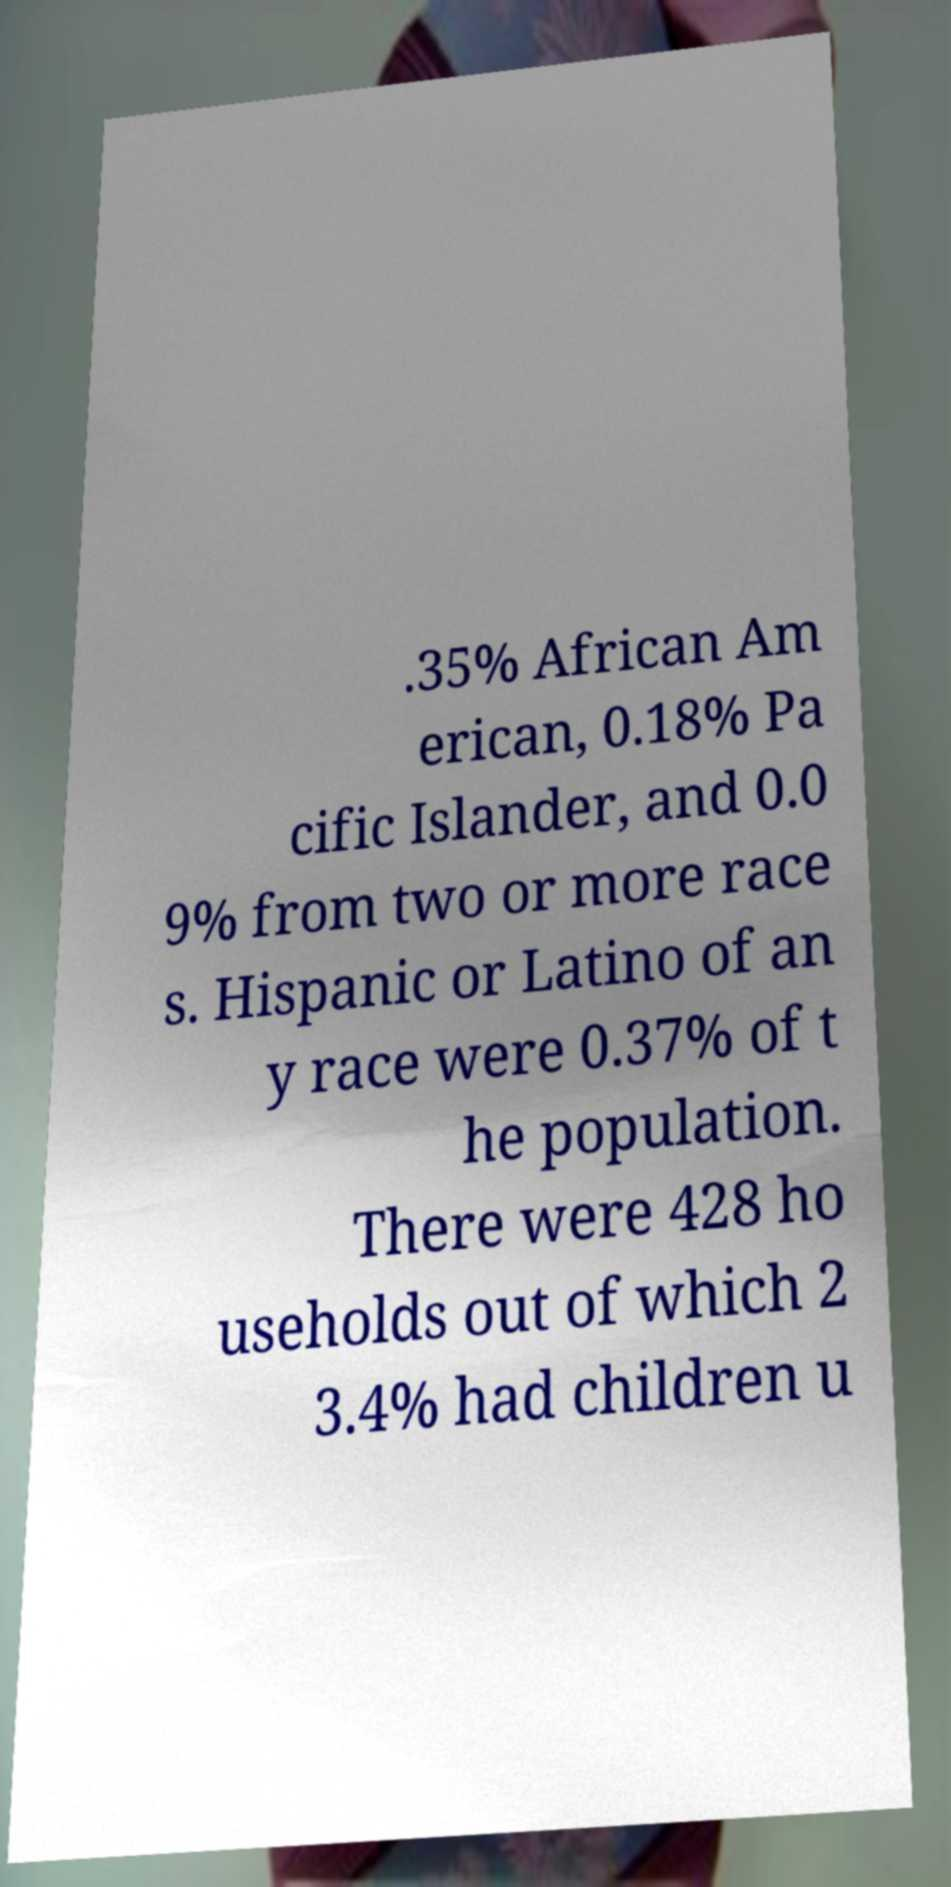Please identify and transcribe the text found in this image. .35% African Am erican, 0.18% Pa cific Islander, and 0.0 9% from two or more race s. Hispanic or Latino of an y race were 0.37% of t he population. There were 428 ho useholds out of which 2 3.4% had children u 